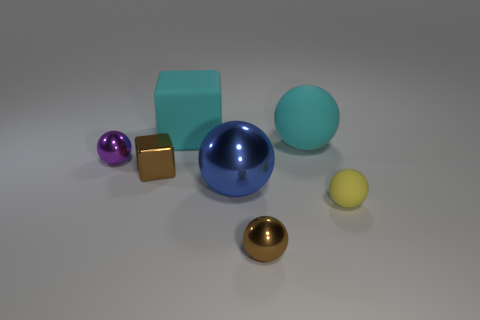There is a tiny ball behind the large metal ball; what is its material?
Give a very brief answer. Metal. There is a blue sphere that is made of the same material as the small purple thing; what is its size?
Offer a terse response. Large. There is a metallic object that is in front of the yellow matte object; is its size the same as the brown metal thing behind the blue sphere?
Your answer should be very brief. Yes. There is a blue sphere that is the same size as the cyan block; what is its material?
Give a very brief answer. Metal. The tiny sphere that is left of the yellow object and right of the small shiny cube is made of what material?
Give a very brief answer. Metal. Are any green shiny things visible?
Make the answer very short. No. There is a tiny shiny block; is it the same color as the tiny shiny object that is on the right side of the cyan matte cube?
Ensure brevity in your answer.  Yes. What is the material of the large cube that is the same color as the large rubber ball?
Your response must be concise. Rubber. The tiny thing that is right of the big ball that is on the right side of the big blue metallic sphere to the right of the small metal cube is what shape?
Keep it short and to the point. Sphere. There is a yellow rubber thing; what shape is it?
Give a very brief answer. Sphere. 